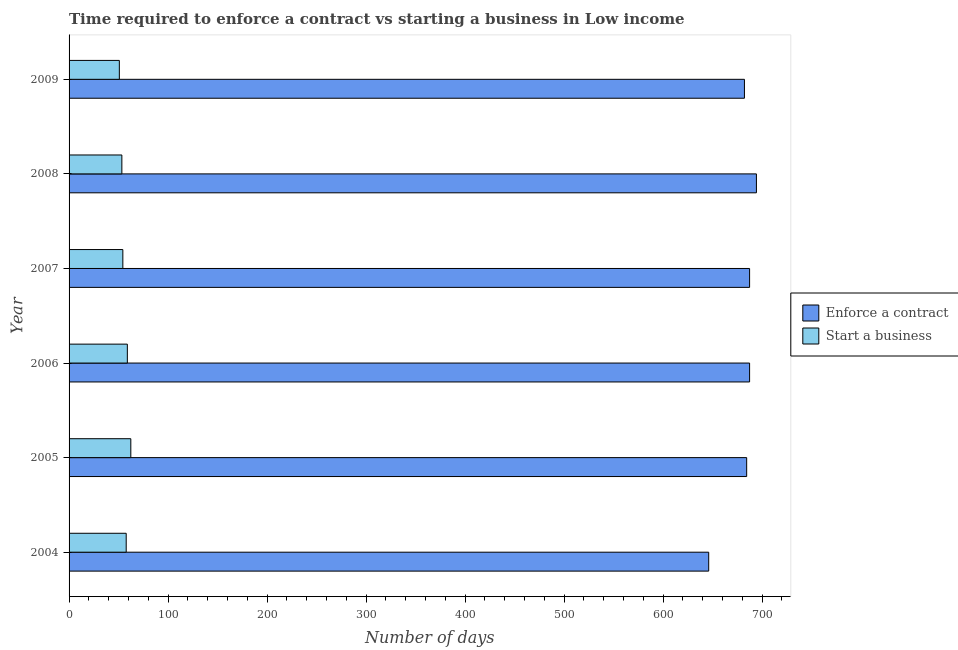How many different coloured bars are there?
Offer a very short reply. 2. How many groups of bars are there?
Ensure brevity in your answer.  6. Are the number of bars on each tick of the Y-axis equal?
Ensure brevity in your answer.  Yes. In how many cases, is the number of bars for a given year not equal to the number of legend labels?
Your answer should be compact. 0. What is the number of days to enforece a contract in 2006?
Keep it short and to the point. 687.39. Across all years, what is the maximum number of days to start a business?
Ensure brevity in your answer.  62.37. Across all years, what is the minimum number of days to enforece a contract?
Ensure brevity in your answer.  646.08. In which year was the number of days to enforece a contract maximum?
Ensure brevity in your answer.  2008. In which year was the number of days to enforece a contract minimum?
Your answer should be compact. 2004. What is the total number of days to start a business in the graph?
Your answer should be very brief. 337.36. What is the difference between the number of days to enforece a contract in 2004 and that in 2005?
Provide a short and direct response. -38.36. What is the difference between the number of days to start a business in 2004 and the number of days to enforece a contract in 2007?
Provide a succinct answer. -629.68. What is the average number of days to start a business per year?
Your answer should be compact. 56.23. In the year 2009, what is the difference between the number of days to start a business and number of days to enforece a contract?
Provide a succinct answer. -631.39. What is the ratio of the number of days to enforece a contract in 2007 to that in 2008?
Offer a terse response. 0.99. What is the difference between the highest and the second highest number of days to start a business?
Your answer should be very brief. 3.51. What is the difference between the highest and the lowest number of days to start a business?
Your answer should be compact. 11.58. In how many years, is the number of days to enforece a contract greater than the average number of days to enforece a contract taken over all years?
Make the answer very short. 5. Is the sum of the number of days to enforece a contract in 2005 and 2006 greater than the maximum number of days to start a business across all years?
Provide a short and direct response. Yes. What does the 2nd bar from the top in 2007 represents?
Give a very brief answer. Enforce a contract. What does the 2nd bar from the bottom in 2007 represents?
Your answer should be compact. Start a business. How many years are there in the graph?
Your response must be concise. 6. Are the values on the major ticks of X-axis written in scientific E-notation?
Offer a very short reply. No. Does the graph contain grids?
Provide a succinct answer. No. What is the title of the graph?
Your answer should be compact. Time required to enforce a contract vs starting a business in Low income. Does "Research and Development" appear as one of the legend labels in the graph?
Give a very brief answer. No. What is the label or title of the X-axis?
Provide a short and direct response. Number of days. What is the Number of days of Enforce a contract in 2004?
Offer a very short reply. 646.08. What is the Number of days in Start a business in 2004?
Your answer should be very brief. 57.71. What is the Number of days of Enforce a contract in 2005?
Offer a very short reply. 684.44. What is the Number of days in Start a business in 2005?
Your response must be concise. 62.37. What is the Number of days of Enforce a contract in 2006?
Give a very brief answer. 687.39. What is the Number of days of Start a business in 2006?
Provide a succinct answer. 58.86. What is the Number of days of Enforce a contract in 2007?
Make the answer very short. 687.39. What is the Number of days of Start a business in 2007?
Ensure brevity in your answer.  54.32. What is the Number of days in Enforce a contract in 2008?
Provide a succinct answer. 694.29. What is the Number of days of Start a business in 2008?
Provide a short and direct response. 53.32. What is the Number of days of Enforce a contract in 2009?
Provide a succinct answer. 682.18. What is the Number of days in Start a business in 2009?
Provide a short and direct response. 50.79. Across all years, what is the maximum Number of days of Enforce a contract?
Your answer should be very brief. 694.29. Across all years, what is the maximum Number of days in Start a business?
Keep it short and to the point. 62.37. Across all years, what is the minimum Number of days of Enforce a contract?
Provide a succinct answer. 646.08. Across all years, what is the minimum Number of days of Start a business?
Your response must be concise. 50.79. What is the total Number of days in Enforce a contract in the graph?
Offer a terse response. 4081.78. What is the total Number of days of Start a business in the graph?
Your answer should be very brief. 337.36. What is the difference between the Number of days in Enforce a contract in 2004 and that in 2005?
Keep it short and to the point. -38.36. What is the difference between the Number of days of Start a business in 2004 and that in 2005?
Give a very brief answer. -4.66. What is the difference between the Number of days in Enforce a contract in 2004 and that in 2006?
Your response must be concise. -41.31. What is the difference between the Number of days in Start a business in 2004 and that in 2006?
Keep it short and to the point. -1.15. What is the difference between the Number of days of Enforce a contract in 2004 and that in 2007?
Offer a terse response. -41.31. What is the difference between the Number of days of Start a business in 2004 and that in 2007?
Ensure brevity in your answer.  3.39. What is the difference between the Number of days in Enforce a contract in 2004 and that in 2008?
Offer a very short reply. -48.2. What is the difference between the Number of days of Start a business in 2004 and that in 2008?
Your answer should be very brief. 4.39. What is the difference between the Number of days in Enforce a contract in 2004 and that in 2009?
Provide a succinct answer. -36.1. What is the difference between the Number of days in Start a business in 2004 and that in 2009?
Offer a very short reply. 6.92. What is the difference between the Number of days in Enforce a contract in 2005 and that in 2006?
Offer a terse response. -2.95. What is the difference between the Number of days of Start a business in 2005 and that in 2006?
Your response must be concise. 3.51. What is the difference between the Number of days of Enforce a contract in 2005 and that in 2007?
Your answer should be very brief. -2.95. What is the difference between the Number of days of Start a business in 2005 and that in 2007?
Offer a terse response. 8.05. What is the difference between the Number of days of Enforce a contract in 2005 and that in 2008?
Provide a succinct answer. -9.84. What is the difference between the Number of days of Start a business in 2005 and that in 2008?
Offer a very short reply. 9.05. What is the difference between the Number of days of Enforce a contract in 2005 and that in 2009?
Your response must be concise. 2.27. What is the difference between the Number of days in Start a business in 2005 and that in 2009?
Provide a short and direct response. 11.58. What is the difference between the Number of days in Enforce a contract in 2006 and that in 2007?
Offer a very short reply. 0. What is the difference between the Number of days of Start a business in 2006 and that in 2007?
Provide a short and direct response. 4.54. What is the difference between the Number of days in Enforce a contract in 2006 and that in 2008?
Your response must be concise. -6.89. What is the difference between the Number of days of Start a business in 2006 and that in 2008?
Make the answer very short. 5.54. What is the difference between the Number of days in Enforce a contract in 2006 and that in 2009?
Your answer should be compact. 5.21. What is the difference between the Number of days of Start a business in 2006 and that in 2009?
Your answer should be very brief. 8.07. What is the difference between the Number of days of Enforce a contract in 2007 and that in 2008?
Your response must be concise. -6.89. What is the difference between the Number of days of Enforce a contract in 2007 and that in 2009?
Offer a terse response. 5.21. What is the difference between the Number of days in Start a business in 2007 and that in 2009?
Offer a very short reply. 3.54. What is the difference between the Number of days of Enforce a contract in 2008 and that in 2009?
Offer a very short reply. 12.11. What is the difference between the Number of days in Start a business in 2008 and that in 2009?
Your answer should be very brief. 2.54. What is the difference between the Number of days in Enforce a contract in 2004 and the Number of days in Start a business in 2005?
Your answer should be very brief. 583.71. What is the difference between the Number of days of Enforce a contract in 2004 and the Number of days of Start a business in 2006?
Provide a short and direct response. 587.23. What is the difference between the Number of days in Enforce a contract in 2004 and the Number of days in Start a business in 2007?
Ensure brevity in your answer.  591.76. What is the difference between the Number of days in Enforce a contract in 2004 and the Number of days in Start a business in 2008?
Offer a terse response. 592.76. What is the difference between the Number of days of Enforce a contract in 2004 and the Number of days of Start a business in 2009?
Your answer should be compact. 595.3. What is the difference between the Number of days of Enforce a contract in 2005 and the Number of days of Start a business in 2006?
Your answer should be compact. 625.59. What is the difference between the Number of days of Enforce a contract in 2005 and the Number of days of Start a business in 2007?
Your answer should be very brief. 630.12. What is the difference between the Number of days of Enforce a contract in 2005 and the Number of days of Start a business in 2008?
Your answer should be compact. 631.12. What is the difference between the Number of days of Enforce a contract in 2005 and the Number of days of Start a business in 2009?
Your response must be concise. 633.66. What is the difference between the Number of days of Enforce a contract in 2006 and the Number of days of Start a business in 2007?
Offer a very short reply. 633.07. What is the difference between the Number of days of Enforce a contract in 2006 and the Number of days of Start a business in 2008?
Provide a succinct answer. 634.07. What is the difference between the Number of days of Enforce a contract in 2006 and the Number of days of Start a business in 2009?
Offer a terse response. 636.61. What is the difference between the Number of days in Enforce a contract in 2007 and the Number of days in Start a business in 2008?
Offer a very short reply. 634.07. What is the difference between the Number of days of Enforce a contract in 2007 and the Number of days of Start a business in 2009?
Provide a short and direct response. 636.61. What is the difference between the Number of days of Enforce a contract in 2008 and the Number of days of Start a business in 2009?
Ensure brevity in your answer.  643.5. What is the average Number of days in Enforce a contract per year?
Ensure brevity in your answer.  680.3. What is the average Number of days in Start a business per year?
Provide a succinct answer. 56.23. In the year 2004, what is the difference between the Number of days in Enforce a contract and Number of days in Start a business?
Your answer should be very brief. 588.38. In the year 2005, what is the difference between the Number of days of Enforce a contract and Number of days of Start a business?
Keep it short and to the point. 622.07. In the year 2006, what is the difference between the Number of days of Enforce a contract and Number of days of Start a business?
Your response must be concise. 628.54. In the year 2007, what is the difference between the Number of days of Enforce a contract and Number of days of Start a business?
Keep it short and to the point. 633.07. In the year 2008, what is the difference between the Number of days in Enforce a contract and Number of days in Start a business?
Give a very brief answer. 640.96. In the year 2009, what is the difference between the Number of days in Enforce a contract and Number of days in Start a business?
Your answer should be compact. 631.39. What is the ratio of the Number of days in Enforce a contract in 2004 to that in 2005?
Offer a very short reply. 0.94. What is the ratio of the Number of days of Start a business in 2004 to that in 2005?
Your response must be concise. 0.93. What is the ratio of the Number of days in Enforce a contract in 2004 to that in 2006?
Make the answer very short. 0.94. What is the ratio of the Number of days in Start a business in 2004 to that in 2006?
Provide a short and direct response. 0.98. What is the ratio of the Number of days of Enforce a contract in 2004 to that in 2007?
Your response must be concise. 0.94. What is the ratio of the Number of days in Start a business in 2004 to that in 2007?
Your answer should be compact. 1.06. What is the ratio of the Number of days of Enforce a contract in 2004 to that in 2008?
Offer a terse response. 0.93. What is the ratio of the Number of days in Start a business in 2004 to that in 2008?
Your response must be concise. 1.08. What is the ratio of the Number of days in Enforce a contract in 2004 to that in 2009?
Your answer should be compact. 0.95. What is the ratio of the Number of days of Start a business in 2004 to that in 2009?
Offer a very short reply. 1.14. What is the ratio of the Number of days in Enforce a contract in 2005 to that in 2006?
Make the answer very short. 1. What is the ratio of the Number of days in Start a business in 2005 to that in 2006?
Provide a short and direct response. 1.06. What is the ratio of the Number of days of Start a business in 2005 to that in 2007?
Offer a terse response. 1.15. What is the ratio of the Number of days of Enforce a contract in 2005 to that in 2008?
Ensure brevity in your answer.  0.99. What is the ratio of the Number of days of Start a business in 2005 to that in 2008?
Offer a terse response. 1.17. What is the ratio of the Number of days in Start a business in 2005 to that in 2009?
Your response must be concise. 1.23. What is the ratio of the Number of days in Enforce a contract in 2006 to that in 2007?
Keep it short and to the point. 1. What is the ratio of the Number of days of Start a business in 2006 to that in 2007?
Make the answer very short. 1.08. What is the ratio of the Number of days in Enforce a contract in 2006 to that in 2008?
Ensure brevity in your answer.  0.99. What is the ratio of the Number of days in Start a business in 2006 to that in 2008?
Keep it short and to the point. 1.1. What is the ratio of the Number of days of Enforce a contract in 2006 to that in 2009?
Your answer should be very brief. 1.01. What is the ratio of the Number of days of Start a business in 2006 to that in 2009?
Ensure brevity in your answer.  1.16. What is the ratio of the Number of days in Start a business in 2007 to that in 2008?
Ensure brevity in your answer.  1.02. What is the ratio of the Number of days of Enforce a contract in 2007 to that in 2009?
Ensure brevity in your answer.  1.01. What is the ratio of the Number of days of Start a business in 2007 to that in 2009?
Your answer should be compact. 1.07. What is the ratio of the Number of days of Enforce a contract in 2008 to that in 2009?
Make the answer very short. 1.02. What is the ratio of the Number of days of Start a business in 2008 to that in 2009?
Your answer should be very brief. 1.05. What is the difference between the highest and the second highest Number of days of Enforce a contract?
Offer a very short reply. 6.89. What is the difference between the highest and the second highest Number of days of Start a business?
Make the answer very short. 3.51. What is the difference between the highest and the lowest Number of days of Enforce a contract?
Make the answer very short. 48.2. What is the difference between the highest and the lowest Number of days in Start a business?
Give a very brief answer. 11.58. 